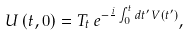Convert formula to latex. <formula><loc_0><loc_0><loc_500><loc_500>U \left ( t , 0 \right ) = T _ { t } \, e ^ { - \frac { i } { } \int _ { 0 } ^ { t } d t ^ { \prime } \, V \left ( t ^ { \prime } \right ) } ,</formula> 